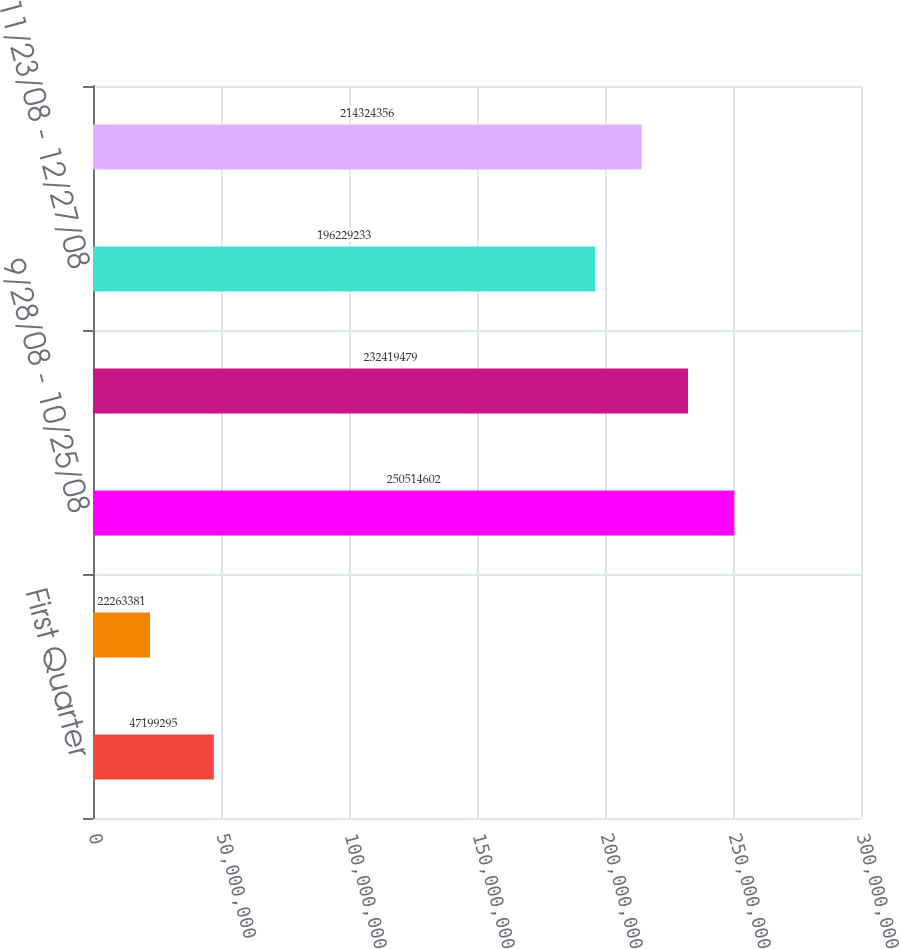<chart> <loc_0><loc_0><loc_500><loc_500><bar_chart><fcel>First Quarter<fcel>Second Quarter<fcel>9/28/08 - 10/25/08<fcel>10/26/08 - 11/22/08<fcel>11/23/08 - 12/27/08<fcel>As of December 27 2008<nl><fcel>4.71993e+07<fcel>2.22634e+07<fcel>2.50515e+08<fcel>2.32419e+08<fcel>1.96229e+08<fcel>2.14324e+08<nl></chart> 